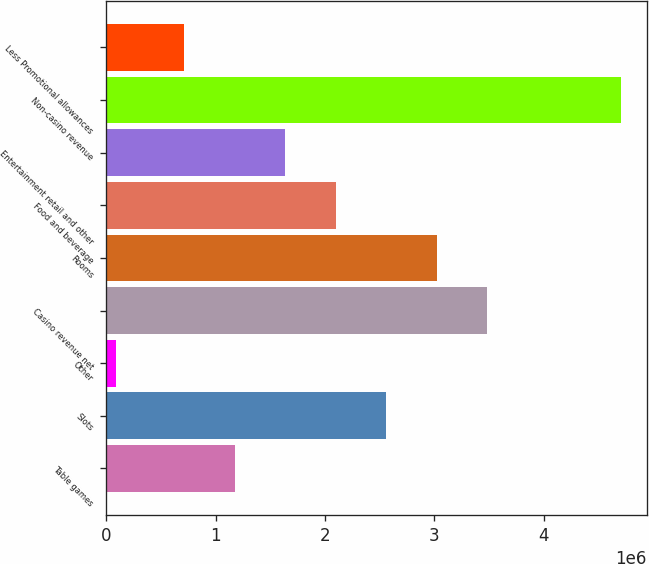Convert chart to OTSL. <chart><loc_0><loc_0><loc_500><loc_500><bar_chart><fcel>Table games<fcel>Slots<fcel>Other<fcel>Casino revenue net<fcel>Rooms<fcel>Food and beverage<fcel>Entertainment retail and other<fcel>Non-casino revenue<fcel>Less Promotional allowances<nl><fcel>1.17205e+06<fcel>2.56031e+06<fcel>83020<fcel>3.48582e+06<fcel>3.02306e+06<fcel>2.09755e+06<fcel>1.6348e+06<fcel>4.71056e+06<fcel>709292<nl></chart> 